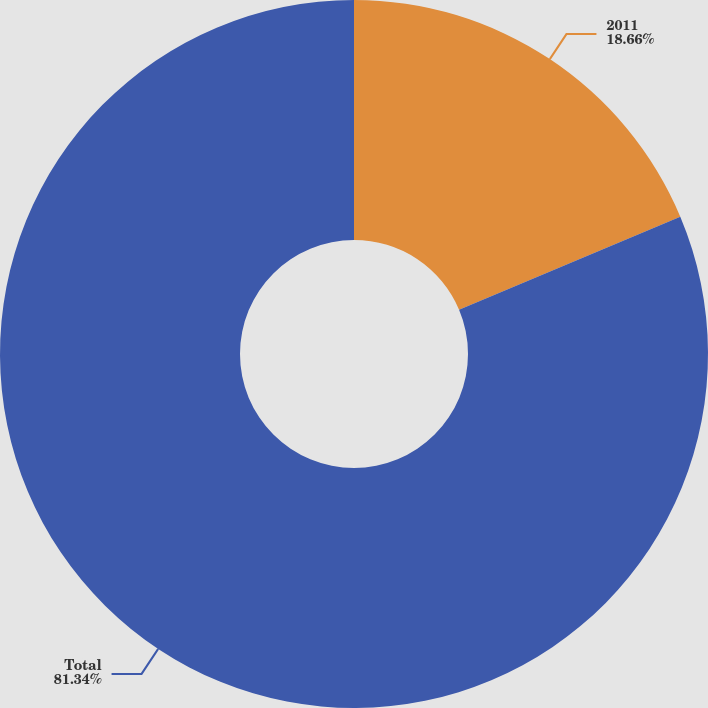<chart> <loc_0><loc_0><loc_500><loc_500><pie_chart><fcel>2011<fcel>Total<nl><fcel>18.66%<fcel>81.34%<nl></chart> 